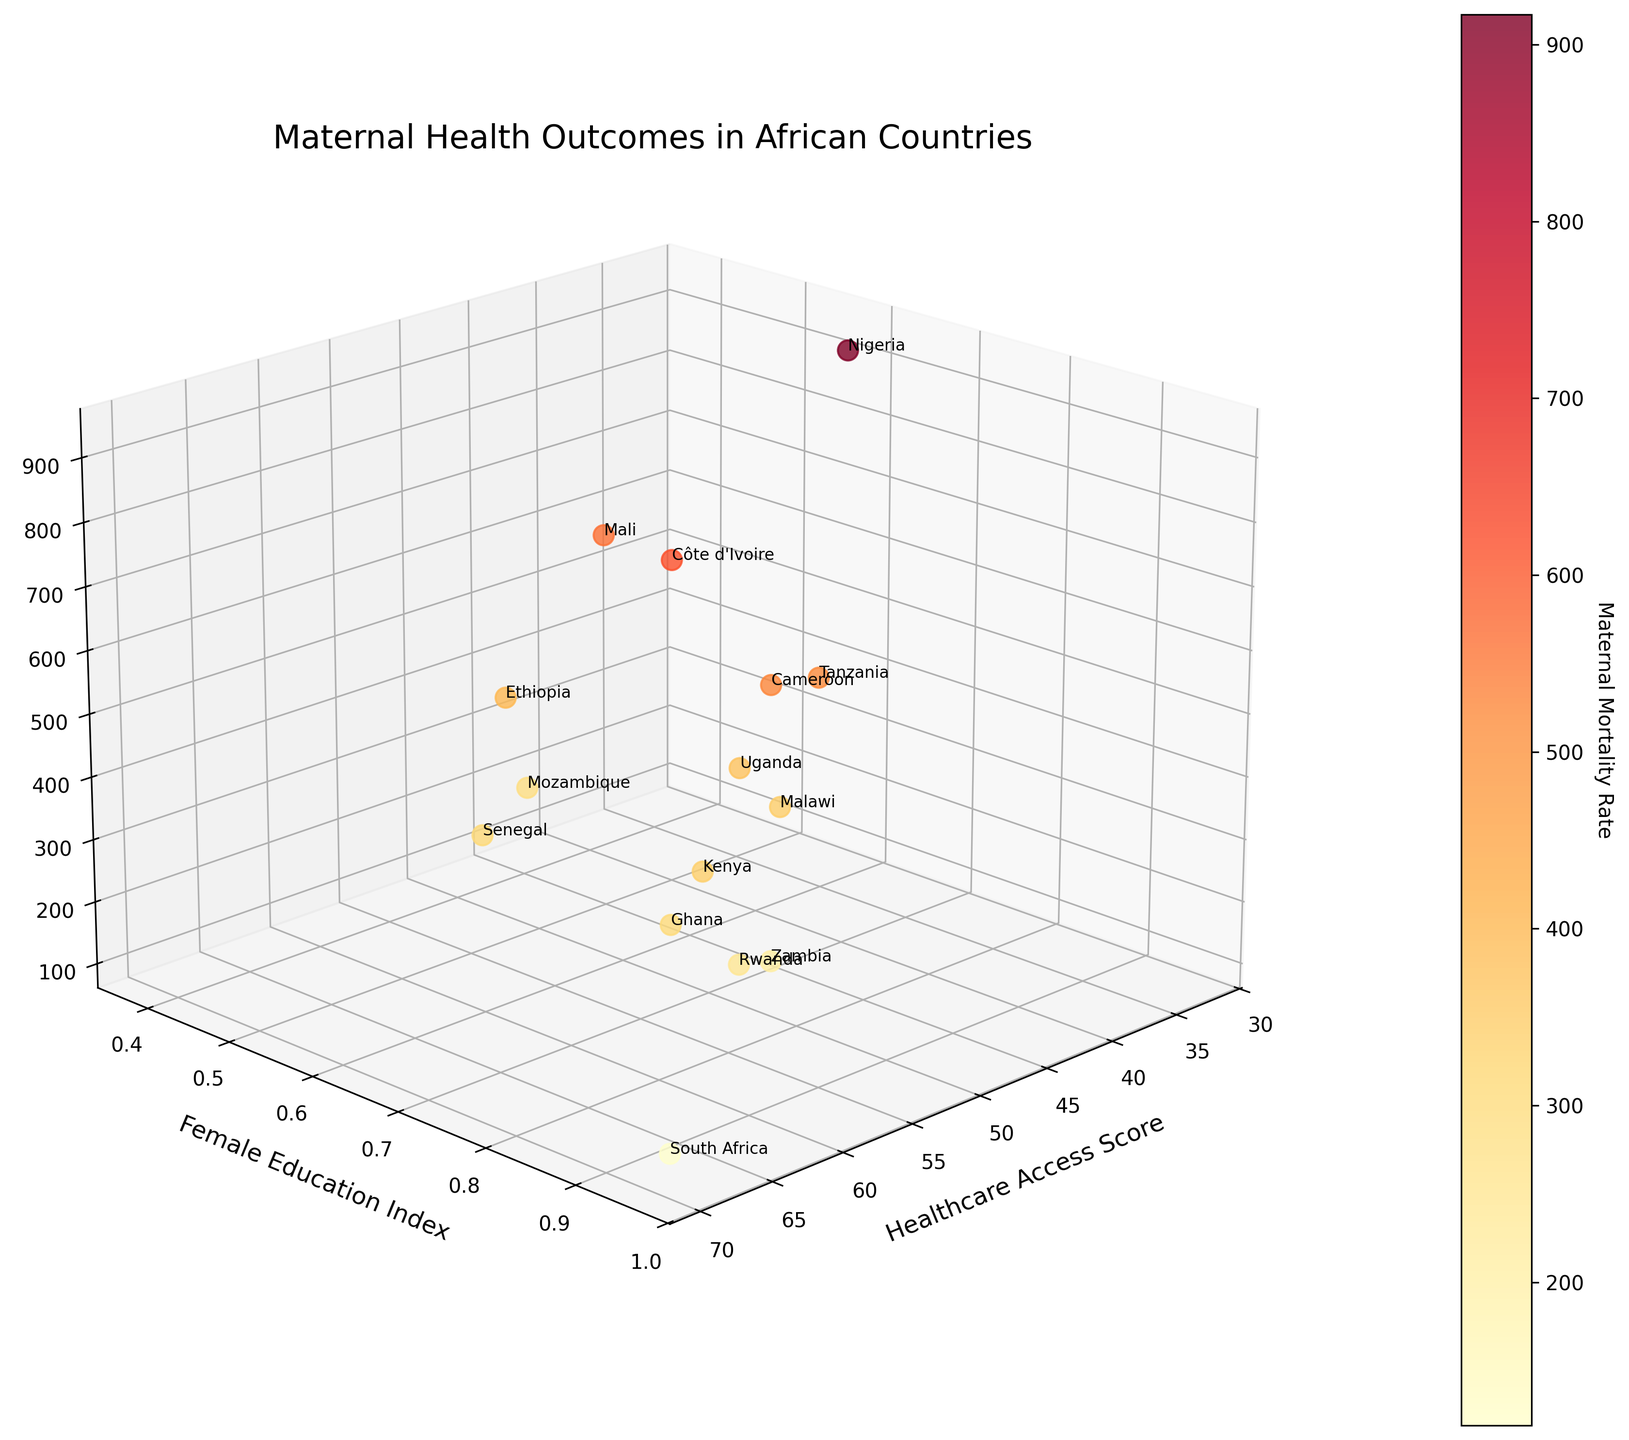What is the maternal mortality rate for Nigeria? Nigeria is labelled on the plot. By finding the point for Nigeria, you can see the value on the "Maternal Mortality Rate" axis.
Answer: 917 Which country has the highest healthcare access score? Look for the country with the highest value along the "Healthcare Access Score" axis.
Answer: South Africa How does female education index correlate with maternal mortality rate in this plot? Observe the vertical and depth positions of points corresponding to high/low values on the "Female Education Index" and "Maternal Mortality Rate" axes. Generally, higher female education index is associated with lower maternal mortality rates.
Answer: Negative correlation What's the title of the plot? The title is displayed at the top of the plot.
Answer: Maternal Health Outcomes in African Countries Comparing Nigeria and South Africa, which country has a lower maternal mortality rate? Compare the positions of Nigeria and South Africa along the "Maternal Mortality Rate" axis.
Answer: South Africa What color represents higher maternal mortality rates in this plot? Notice the color gradient used in the plot for different maternal mortality rates. The higher rates are represented by darker red.
Answer: Darker red Which country has a similar healthcare access score to Ghana but a higher maternal mortality rate? Identify countries close to Ghana on the "Healthcare Access Score" axis, and then find one with a higher "Maternal Mortality Rate".
Answer: Côte d'Ivoire What is the female education index of the country with the lowest maternal mortality rate? Identify the country with the lowest value on the "Maternal Mortality Rate" axis, then check its "Female Education Index".
Answer: South Africa has an index of 0.96 How many countries have a healthcare access score above 50? Count the points that have a "Healthcare Access Score" value greater than 50.
Answer: 7 